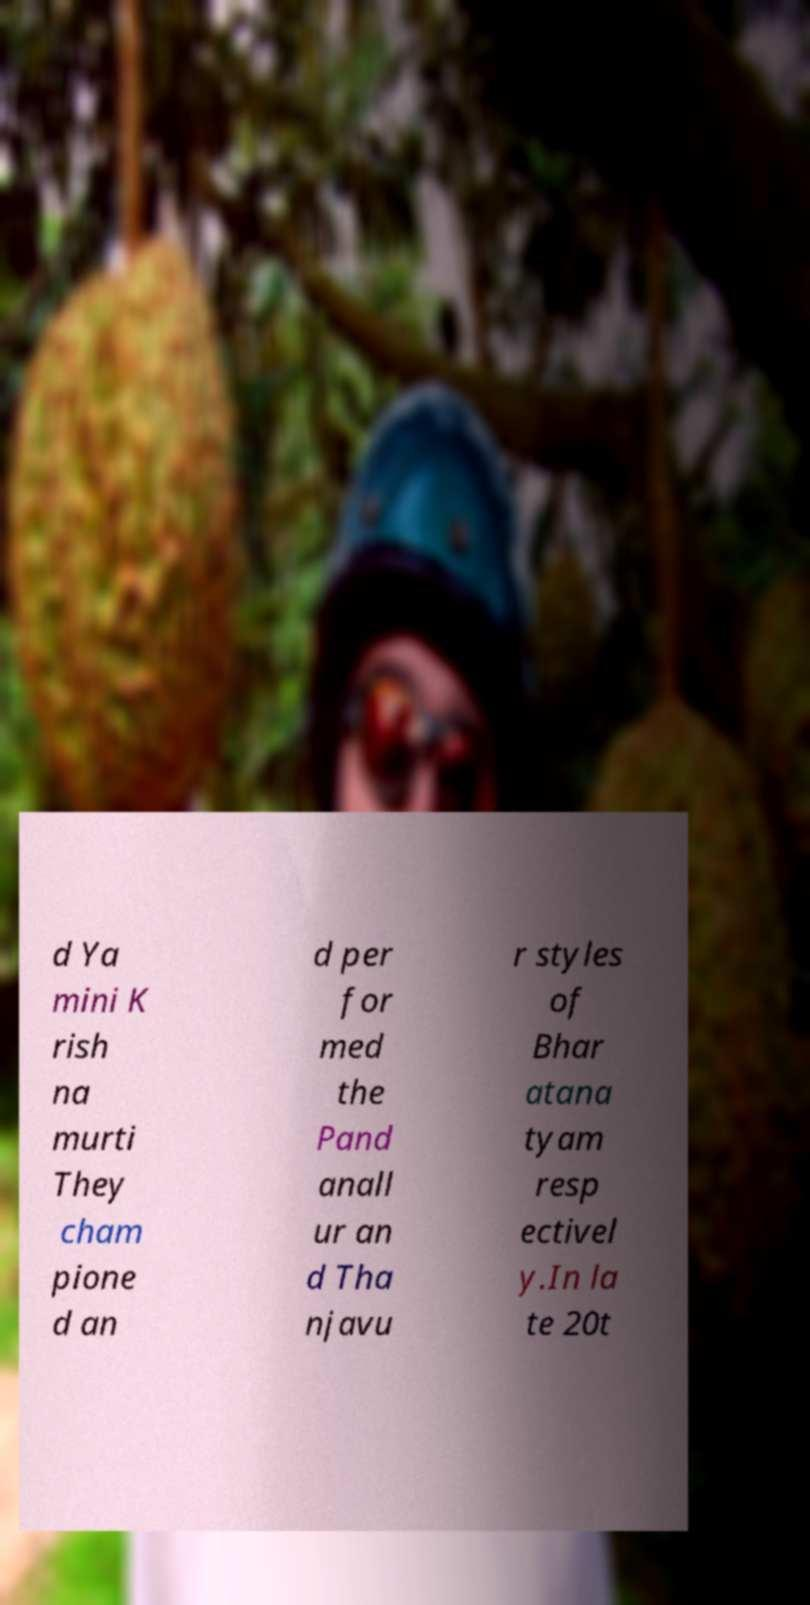Please identify and transcribe the text found in this image. d Ya mini K rish na murti They cham pione d an d per for med the Pand anall ur an d Tha njavu r styles of Bhar atana tyam resp ectivel y.In la te 20t 